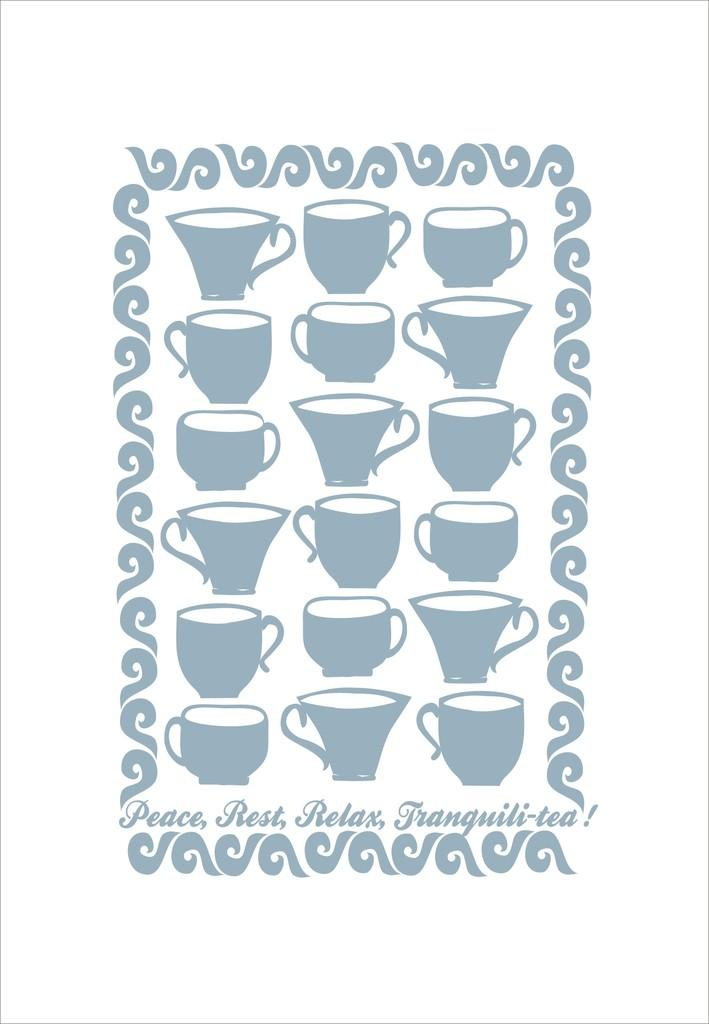What is featured on the poster in the image? The poster contains different types of cups. Is there any text on the poster? Yes, there is text on the poster. Can you see any birds flying in the alley in the image? There is no alley or birds present in the image; it features a poster with cups and text. Is there a hose visible in the image? There is no hose present in the image. 